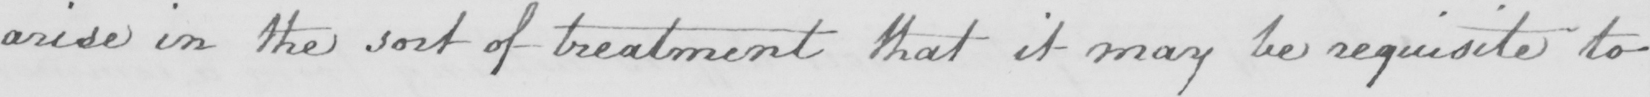Transcribe the text shown in this historical manuscript line. arise in the sort of treatment that it may be requisite to 